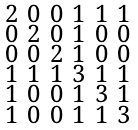<formula> <loc_0><loc_0><loc_500><loc_500>\begin{smallmatrix} 2 & 0 & 0 & 1 & 1 & 1 \\ 0 & 2 & 0 & 1 & 0 & 0 \\ 0 & 0 & 2 & 1 & 0 & 0 \\ 1 & 1 & 1 & 3 & 1 & 1 \\ 1 & 0 & 0 & 1 & 3 & 1 \\ 1 & 0 & 0 & 1 & 1 & 3 \end{smallmatrix}</formula> 